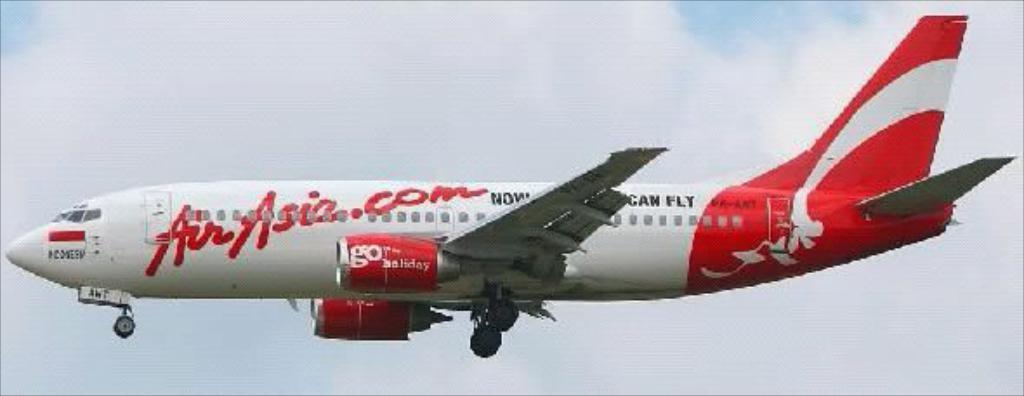Could you give a brief overview of what you see in this image? In this image we can see an aeroplane flying in the air. In the background we can see clouds in the sky. 